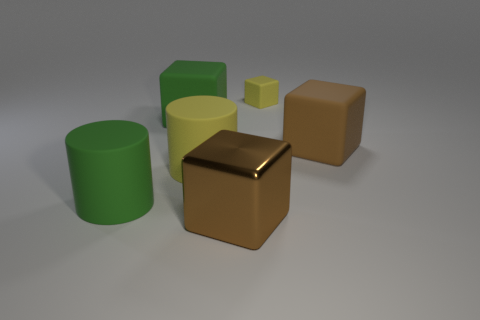Add 1 large yellow rubber objects. How many objects exist? 7 Subtract all blocks. How many objects are left? 2 Subtract all large green matte cylinders. Subtract all yellow rubber things. How many objects are left? 3 Add 5 big yellow objects. How many big yellow objects are left? 6 Add 5 rubber cylinders. How many rubber cylinders exist? 7 Subtract 0 cyan blocks. How many objects are left? 6 